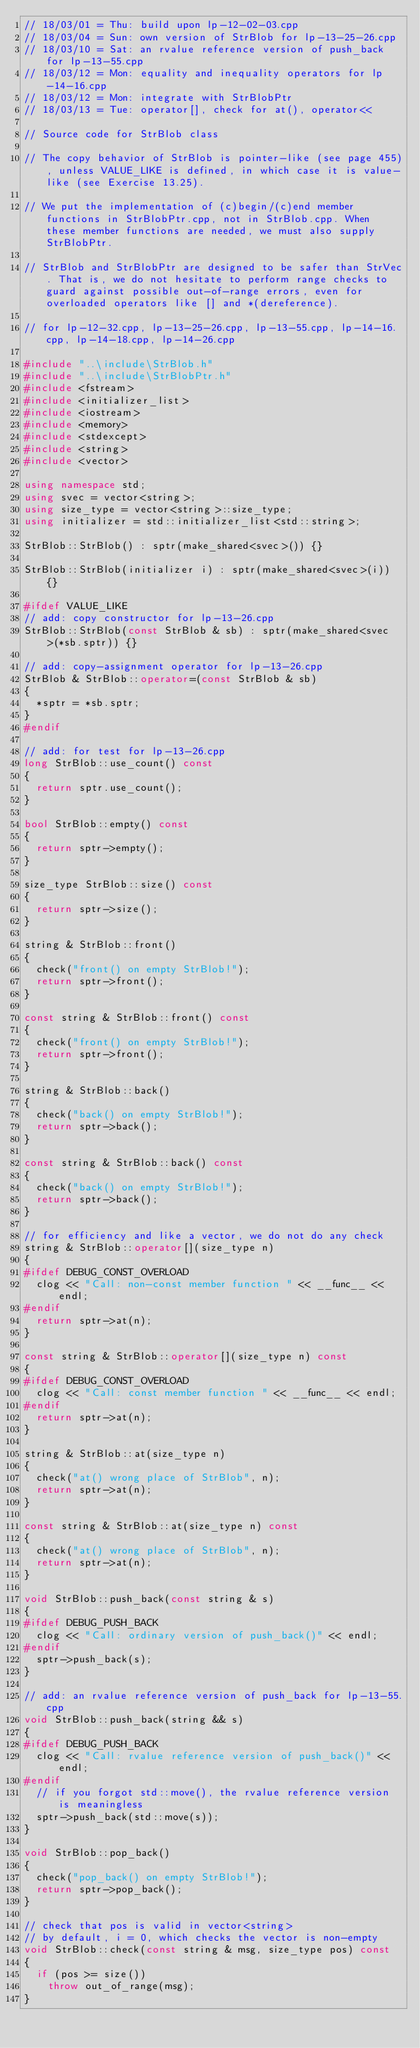Convert code to text. <code><loc_0><loc_0><loc_500><loc_500><_C++_>// 18/03/01 = Thu: build upon lp-12-02-03.cpp
// 18/03/04 = Sun: own version of StrBlob for lp-13-25-26.cpp
// 18/03/10 = Sat: an rvalue reference version of push_back for lp-13-55.cpp
// 18/03/12 = Mon: equality and inequality operators for lp-14-16.cpp
// 18/03/12 = Mon: integrate with StrBlobPtr
// 18/03/13 = Tue: operator[], check for at(), operator<<

// Source code for StrBlob class

// The copy behavior of StrBlob is pointer-like (see page 455), unless VALUE_LIKE is defined, in which case it is value-like (see Exercise 13.25).

// We put the implementation of (c)begin/(c)end member functions in StrBlobPtr.cpp, not in StrBlob.cpp. When these member functions are needed, we must also supply StrBlobPtr.

// StrBlob and StrBlobPtr are designed to be safer than StrVec. That is, we do not hesitate to perform range checks to guard against possible out-of-range errors, even for overloaded operators like [] and *(dereference).

// for lp-12-32.cpp, lp-13-25-26.cpp, lp-13-55.cpp, lp-14-16.cpp, lp-14-18.cpp, lp-14-26.cpp

#include "..\include\StrBlob.h"
#include "..\include\StrBlobPtr.h"
#include <fstream>
#include <initializer_list>
#include <iostream>
#include <memory>
#include <stdexcept>
#include <string>
#include <vector>

using namespace std;
using svec = vector<string>;
using size_type = vector<string>::size_type;
using initializer = std::initializer_list<std::string>;

StrBlob::StrBlob() : sptr(make_shared<svec>()) {}

StrBlob::StrBlob(initializer i) : sptr(make_shared<svec>(i)) {}

#ifdef VALUE_LIKE
// add: copy constructor for lp-13-26.cpp
StrBlob::StrBlob(const StrBlob & sb) : sptr(make_shared<svec>(*sb.sptr)) {}

// add: copy-assignment operator for lp-13-26.cpp
StrBlob & StrBlob::operator=(const StrBlob & sb)
{
	*sptr = *sb.sptr;
}
#endif

// add: for test for lp-13-26.cpp
long StrBlob::use_count() const
{
	return sptr.use_count();
}

bool StrBlob::empty() const
{
	return sptr->empty();
}

size_type StrBlob::size() const
{
	return sptr->size();
}

string & StrBlob::front()
{	
	check("front() on empty StrBlob!");
	return sptr->front();
}

const string & StrBlob::front() const
{	
	check("front() on empty StrBlob!");
	return sptr->front();
}

string & StrBlob::back()
{	
	check("back() on empty StrBlob!");
	return sptr->back();
}

const string & StrBlob::back() const
{	
	check("back() on empty StrBlob!");
	return sptr->back();
}

// for efficiency and like a vector, we do not do any check
string & StrBlob::operator[](size_type n)
{
#ifdef DEBUG_CONST_OVERLOAD
	clog << "Call: non-const member function " << __func__ << endl;
#endif
	return sptr->at(n);
}

const string & StrBlob::operator[](size_type n) const
{
#ifdef DEBUG_CONST_OVERLOAD
	clog << "Call: const member function " << __func__ << endl;
#endif
	return sptr->at(n);
}

string & StrBlob::at(size_type n)
{
	check("at() wrong place of StrBlob", n);
	return sptr->at(n);
}

const string & StrBlob::at(size_type n) const
{
	check("at() wrong place of StrBlob", n);
	return sptr->at(n);
}

void StrBlob::push_back(const string & s)
{
#ifdef DEBUG_PUSH_BACK
	clog << "Call: ordinary version of push_back()" << endl;
#endif
	sptr->push_back(s);
}

// add: an rvalue reference version of push_back for lp-13-55.cpp
void StrBlob::push_back(string && s)
{
#ifdef DEBUG_PUSH_BACK
	clog << "Call: rvalue reference version of push_back()" << endl;
#endif
	// if you forgot std::move(), the rvalue reference version is meaningless
	sptr->push_back(std::move(s));
}

void StrBlob::pop_back()
{	
	check("pop_back() on empty StrBlob!");
	return sptr->pop_back();
}

// check that pos is valid in vector<string>
// by default, i = 0, which checks the vector is non-empty
void StrBlob::check(const string & msg, size_type pos) const
{
	if (pos >= size())
		throw out_of_range(msg);
}
</code> 